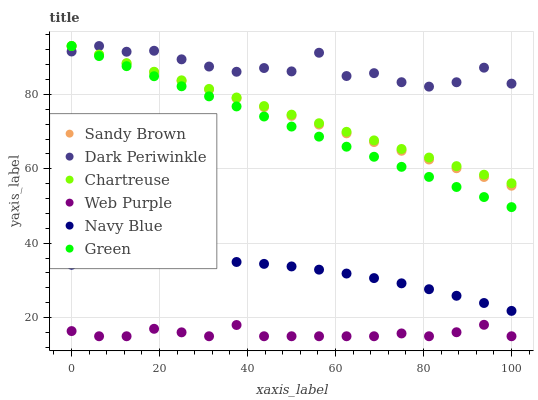Does Web Purple have the minimum area under the curve?
Answer yes or no. Yes. Does Dark Periwinkle have the maximum area under the curve?
Answer yes or no. Yes. Does Chartreuse have the minimum area under the curve?
Answer yes or no. No. Does Chartreuse have the maximum area under the curve?
Answer yes or no. No. Is Chartreuse the smoothest?
Answer yes or no. Yes. Is Dark Periwinkle the roughest?
Answer yes or no. Yes. Is Web Purple the smoothest?
Answer yes or no. No. Is Web Purple the roughest?
Answer yes or no. No. Does Web Purple have the lowest value?
Answer yes or no. Yes. Does Chartreuse have the lowest value?
Answer yes or no. No. Does Dark Periwinkle have the highest value?
Answer yes or no. Yes. Does Web Purple have the highest value?
Answer yes or no. No. Is Web Purple less than Green?
Answer yes or no. Yes. Is Dark Periwinkle greater than Web Purple?
Answer yes or no. Yes. Does Sandy Brown intersect Dark Periwinkle?
Answer yes or no. Yes. Is Sandy Brown less than Dark Periwinkle?
Answer yes or no. No. Is Sandy Brown greater than Dark Periwinkle?
Answer yes or no. No. Does Web Purple intersect Green?
Answer yes or no. No. 